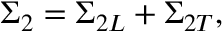Convert formula to latex. <formula><loc_0><loc_0><loc_500><loc_500>\Sigma _ { 2 } = \Sigma _ { 2 L } + \Sigma _ { 2 T } ,</formula> 